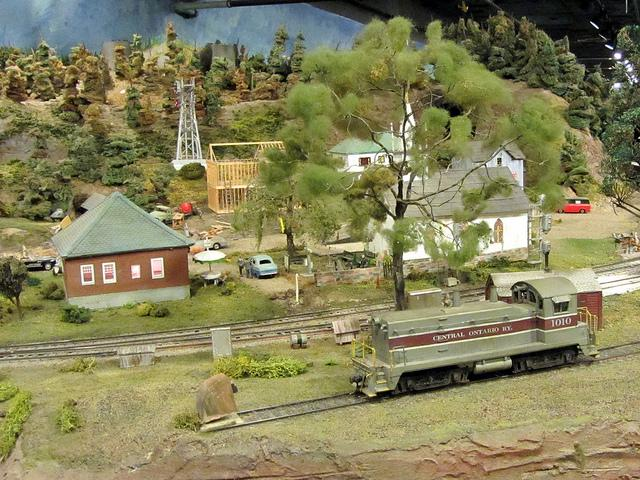What type of scene is this?

Choices:
A) power plant
B) train station
C) model
D) farm model 